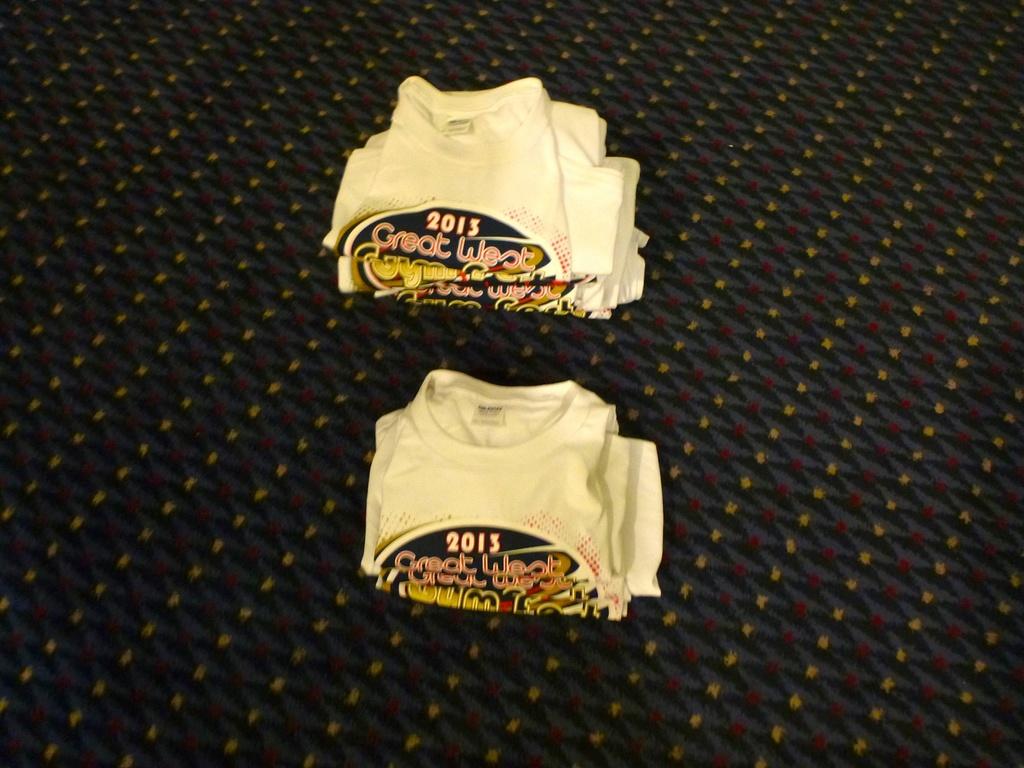What color is the shirt?
Give a very brief answer. White. 